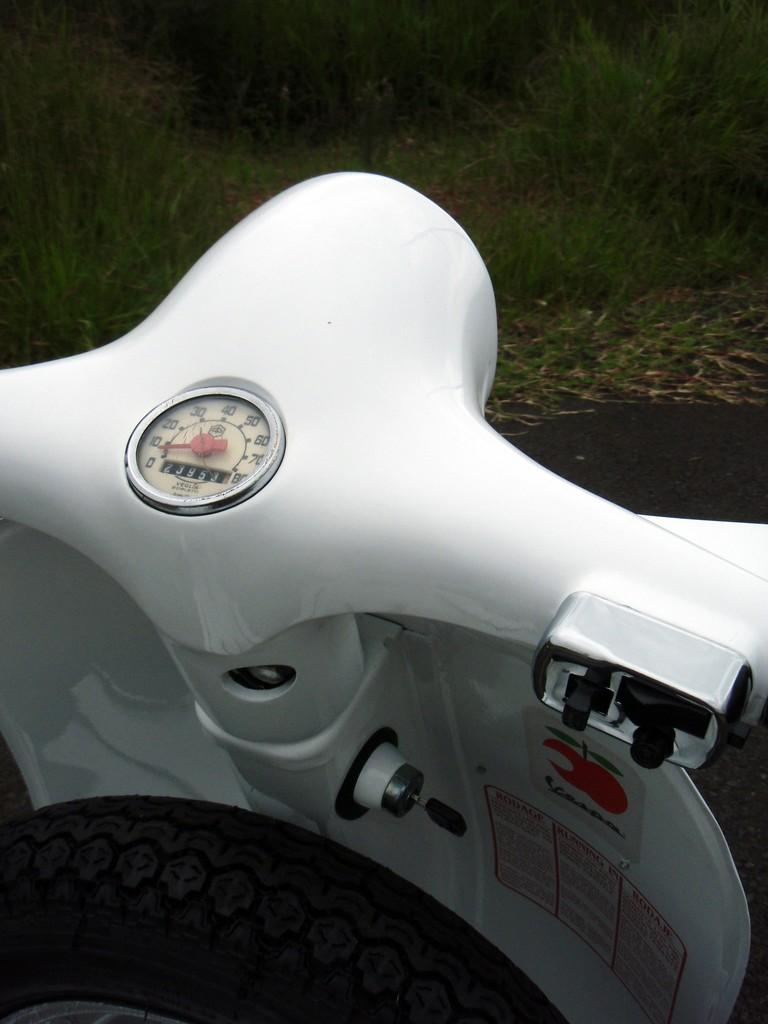What type of vehicle is partially visible in the image? There is a part of a scooter in the image. What is the terrain surrounding the scooter? There is grass visible on the backside of the scooter. What type of knowledge can be gained from playing the game depicted in the image? There is no game present in the image, so no knowledge can be gained from playing a game in this context. 